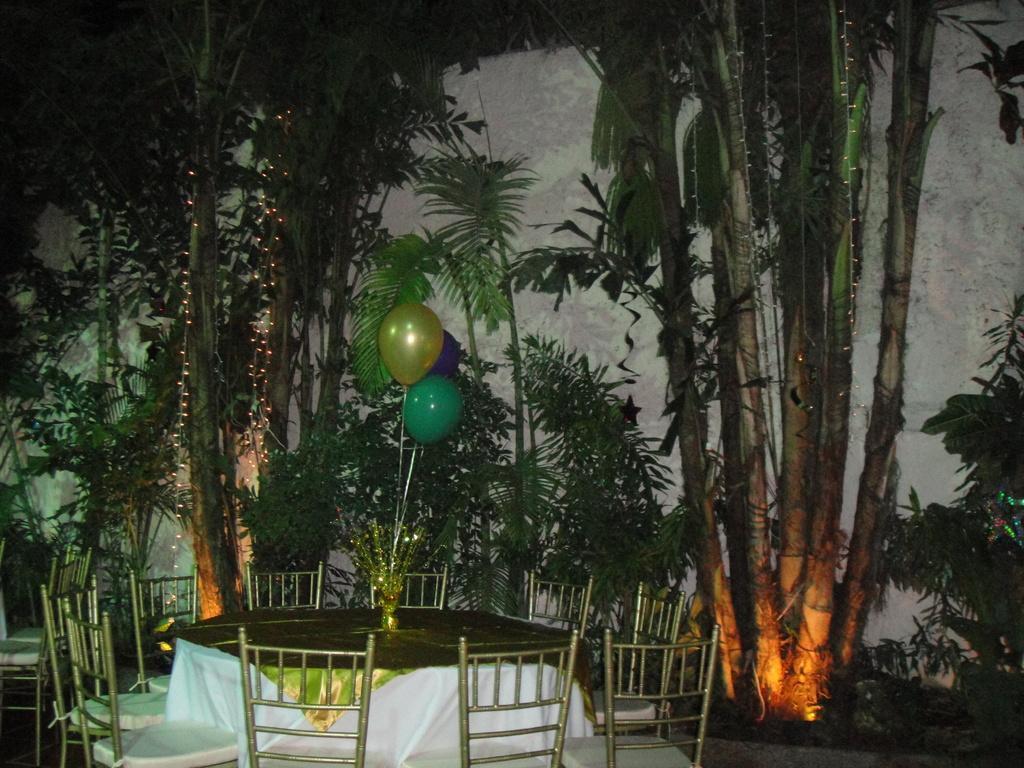Please provide a concise description of this image. In this picture we can see chairs, table on the ground, cloth, balloons, lights, some objects and in the background we can see the wall, trees. 